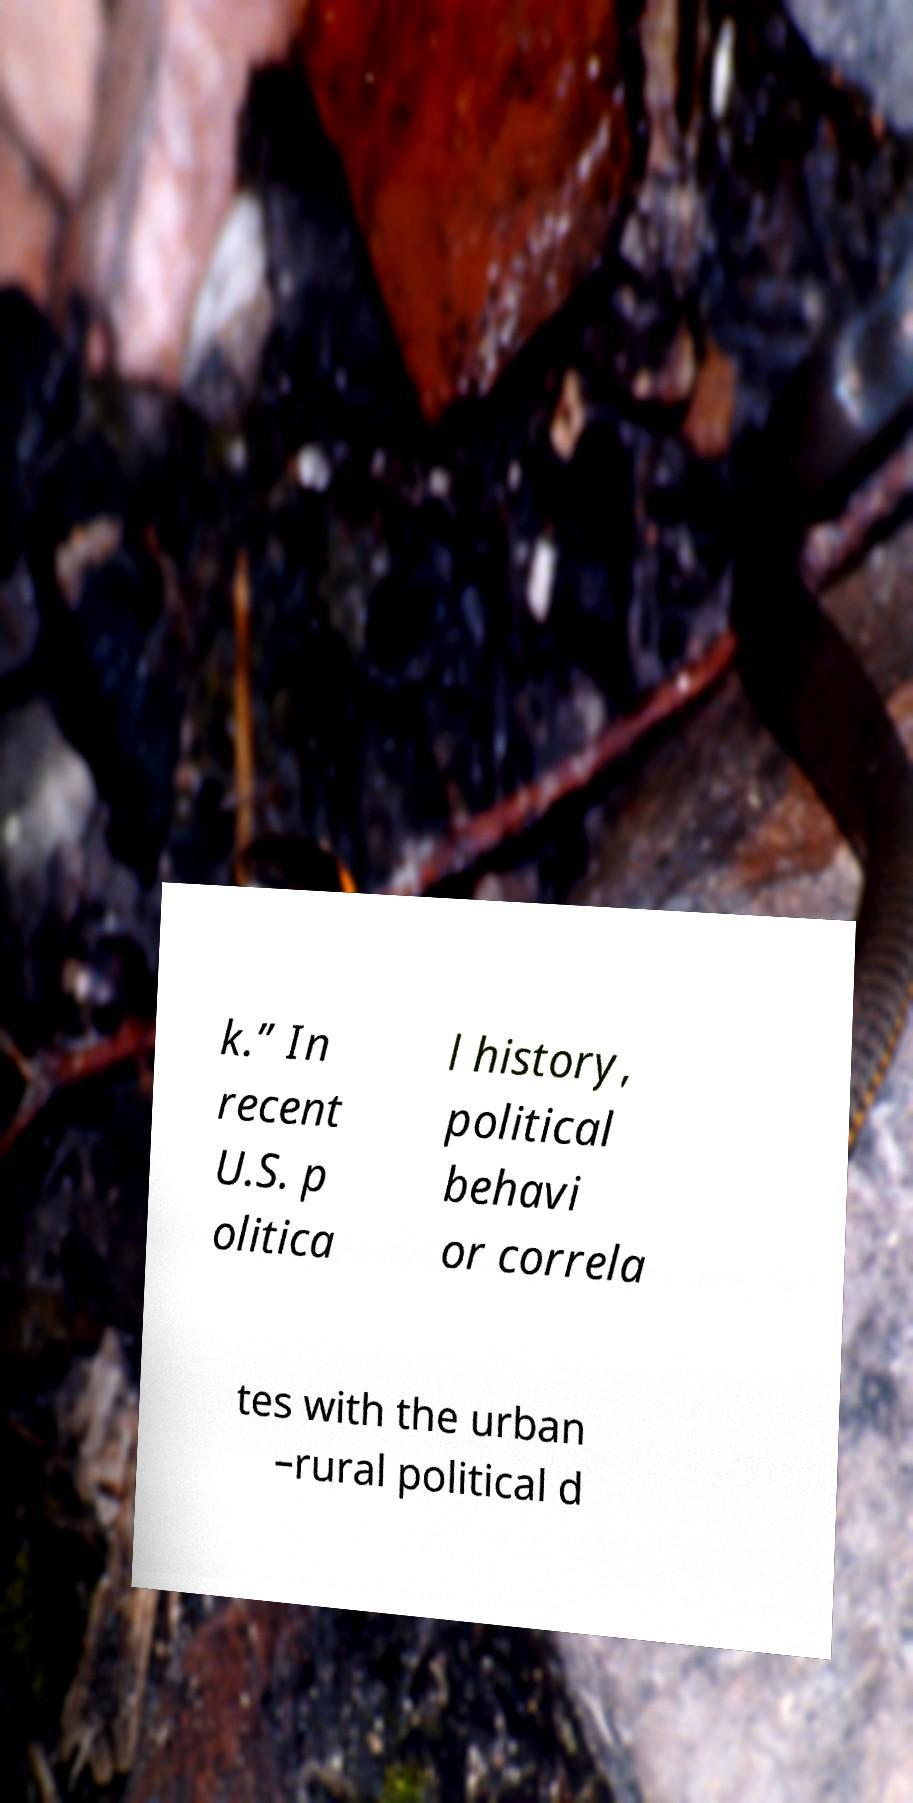Can you read and provide the text displayed in the image?This photo seems to have some interesting text. Can you extract and type it out for me? k.” In recent U.S. p olitica l history, political behavi or correla tes with the urban –rural political d 